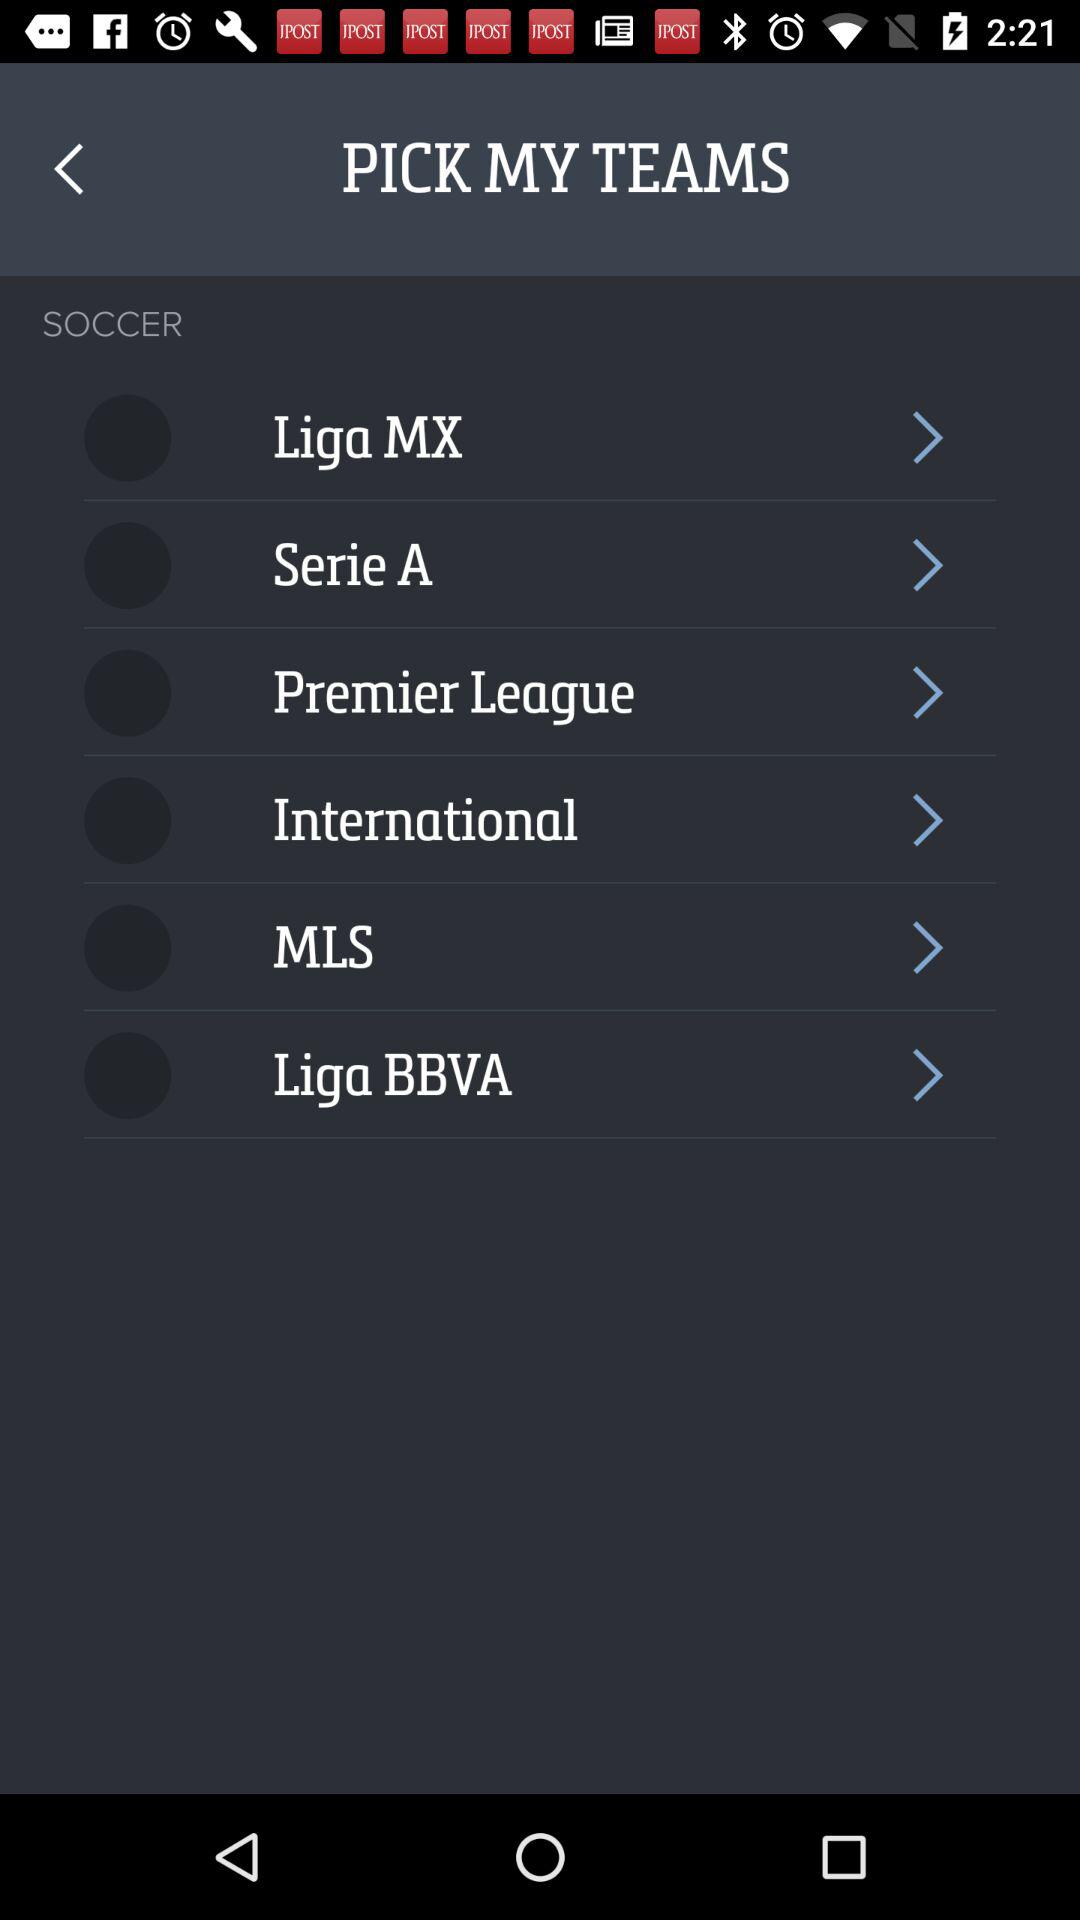How many leagues are displayed before the MLS?
Answer the question using a single word or phrase. 4 